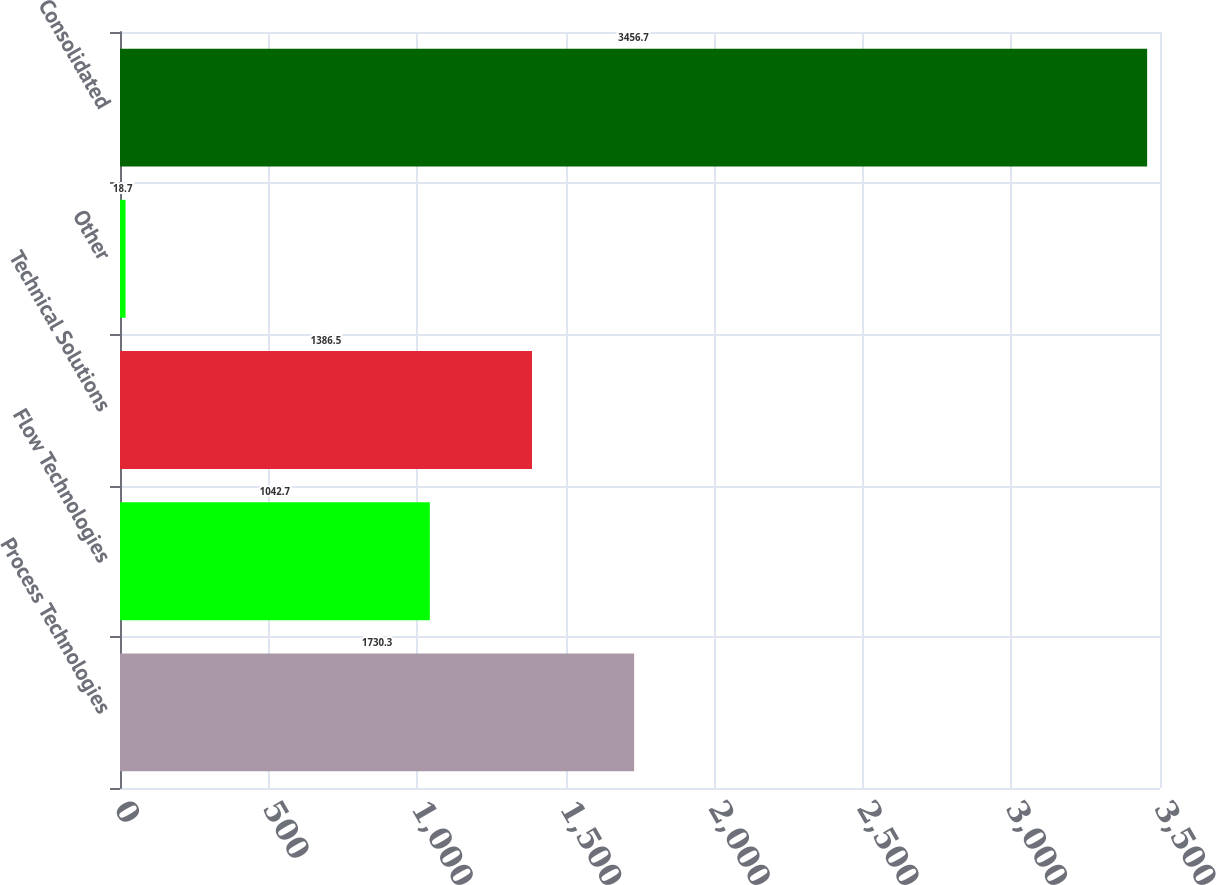Convert chart to OTSL. <chart><loc_0><loc_0><loc_500><loc_500><bar_chart><fcel>Process Technologies<fcel>Flow Technologies<fcel>Technical Solutions<fcel>Other<fcel>Consolidated<nl><fcel>1730.3<fcel>1042.7<fcel>1386.5<fcel>18.7<fcel>3456.7<nl></chart> 